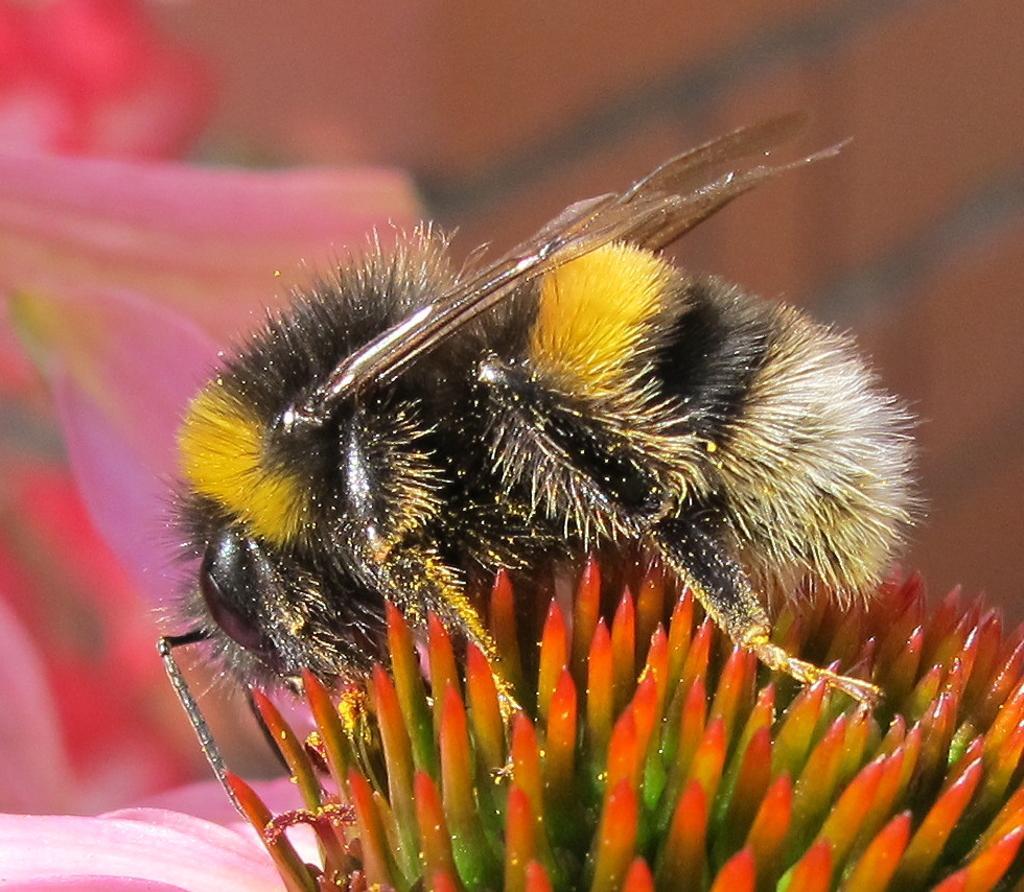Could you give a brief overview of what you see in this image? In the foreground of this image, there is an insect on a flower. In the background, there are pink flowers and on the top right the image is blurred. 